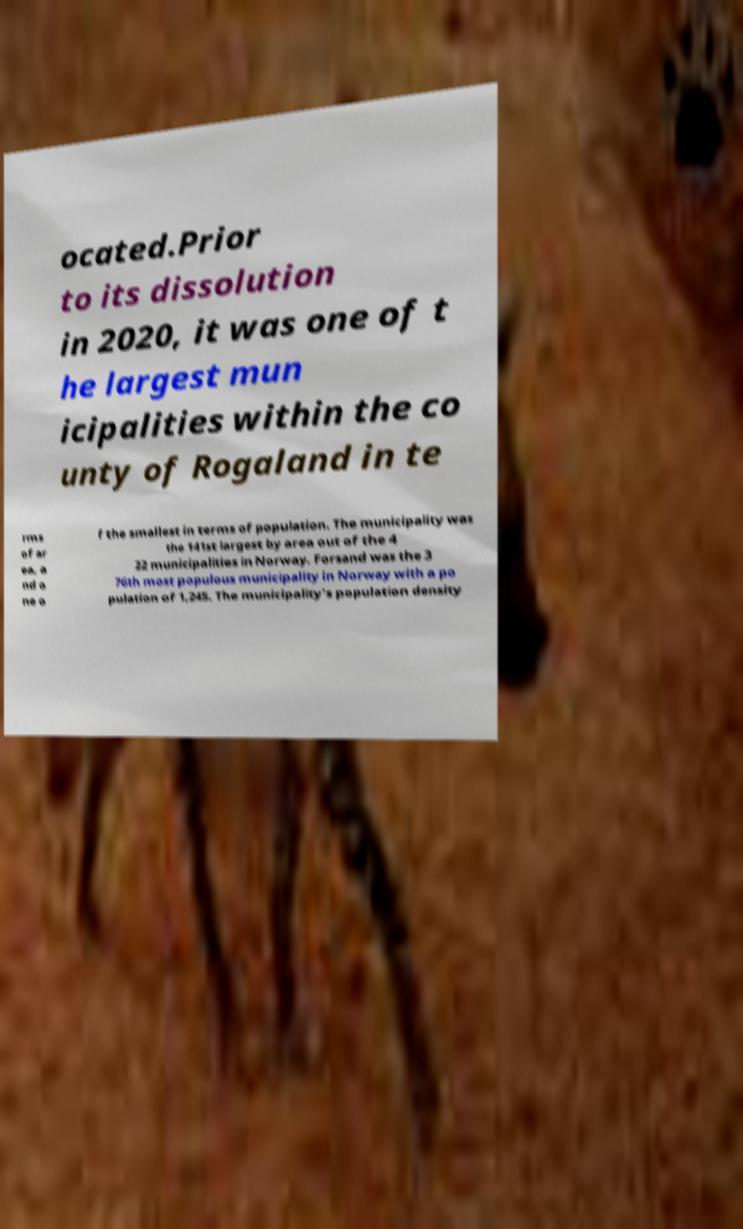What messages or text are displayed in this image? I need them in a readable, typed format. ocated.Prior to its dissolution in 2020, it was one of t he largest mun icipalities within the co unty of Rogaland in te rms of ar ea, a nd o ne o f the smallest in terms of population. The municipality was the 141st largest by area out of the 4 22 municipalities in Norway. Forsand was the 3 76th most populous municipality in Norway with a po pulation of 1,245. The municipality's population density 